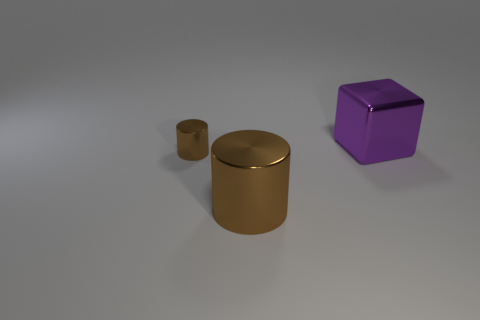Are there fewer big purple metallic blocks to the right of the small metal cylinder than big metal objects?
Your answer should be very brief. Yes. What is the big object in front of the small brown cylinder made of?
Provide a short and direct response. Metal. What number of other things are the same size as the purple cube?
Provide a short and direct response. 1. Is the number of purple shiny objects less than the number of shiny cylinders?
Make the answer very short. Yes. The purple object has what shape?
Your answer should be very brief. Cube. There is a cylinder right of the tiny brown metallic thing; is its color the same as the small shiny object?
Ensure brevity in your answer.  Yes. The object that is both left of the cube and right of the small metallic cylinder has what shape?
Your answer should be compact. Cylinder. There is a object that is behind the small brown shiny thing; what color is it?
Your answer should be very brief. Purple. Is there anything else of the same color as the tiny metallic cylinder?
Offer a terse response. Yes. There is a metal object that is both to the right of the small brown object and left of the purple metallic block; what size is it?
Your answer should be very brief. Large. 